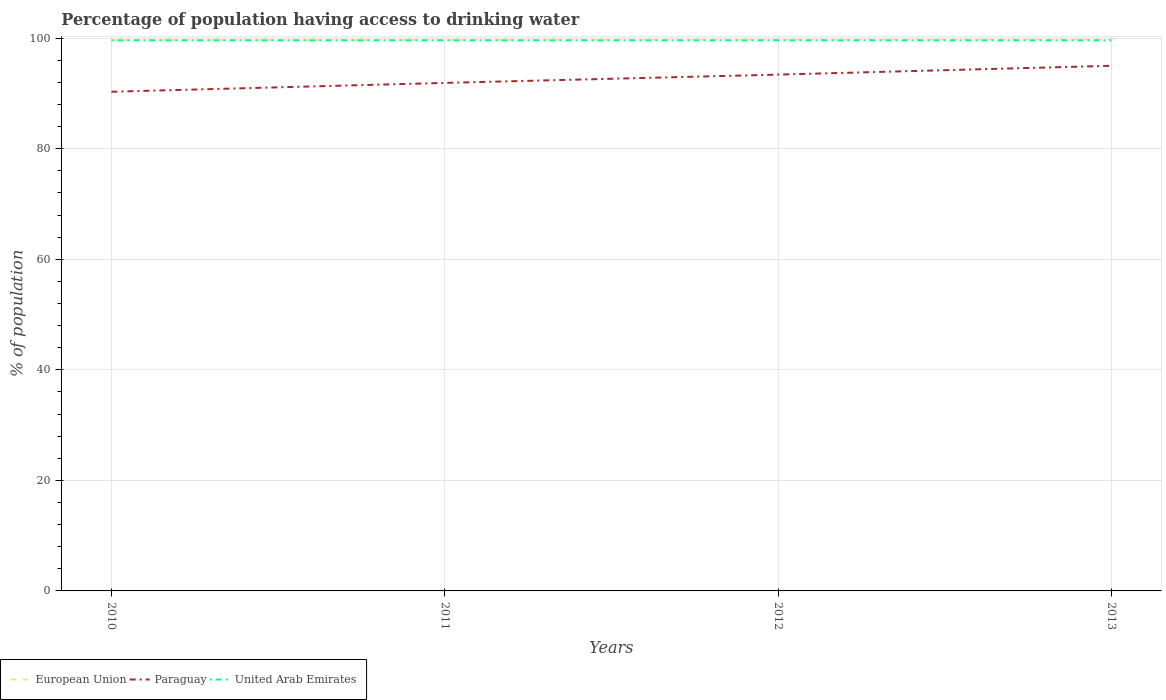Across all years, what is the maximum percentage of population having access to drinking water in Paraguay?
Your response must be concise. 90.3. What is the total percentage of population having access to drinking water in United Arab Emirates in the graph?
Your answer should be very brief. 0. What is the difference between the highest and the second highest percentage of population having access to drinking water in Paraguay?
Keep it short and to the point. 4.7. How many lines are there?
Your answer should be compact. 3. How many years are there in the graph?
Offer a very short reply. 4. What is the difference between two consecutive major ticks on the Y-axis?
Your response must be concise. 20. Does the graph contain any zero values?
Your answer should be very brief. No. How many legend labels are there?
Provide a short and direct response. 3. How are the legend labels stacked?
Provide a short and direct response. Horizontal. What is the title of the graph?
Make the answer very short. Percentage of population having access to drinking water. Does "Sri Lanka" appear as one of the legend labels in the graph?
Keep it short and to the point. No. What is the label or title of the X-axis?
Your answer should be very brief. Years. What is the label or title of the Y-axis?
Provide a succinct answer. % of population. What is the % of population in European Union in 2010?
Your answer should be very brief. 99.61. What is the % of population in Paraguay in 2010?
Give a very brief answer. 90.3. What is the % of population of United Arab Emirates in 2010?
Give a very brief answer. 99.6. What is the % of population of European Union in 2011?
Make the answer very short. 99.68. What is the % of population in Paraguay in 2011?
Provide a short and direct response. 91.9. What is the % of population in United Arab Emirates in 2011?
Give a very brief answer. 99.6. What is the % of population of European Union in 2012?
Your answer should be compact. 99.74. What is the % of population of Paraguay in 2012?
Make the answer very short. 93.4. What is the % of population of United Arab Emirates in 2012?
Ensure brevity in your answer.  99.6. What is the % of population of European Union in 2013?
Provide a short and direct response. 99.81. What is the % of population of United Arab Emirates in 2013?
Offer a terse response. 99.6. Across all years, what is the maximum % of population of European Union?
Your answer should be very brief. 99.81. Across all years, what is the maximum % of population in United Arab Emirates?
Your answer should be very brief. 99.6. Across all years, what is the minimum % of population of European Union?
Make the answer very short. 99.61. Across all years, what is the minimum % of population in Paraguay?
Make the answer very short. 90.3. Across all years, what is the minimum % of population of United Arab Emirates?
Provide a succinct answer. 99.6. What is the total % of population of European Union in the graph?
Offer a terse response. 398.84. What is the total % of population of Paraguay in the graph?
Offer a terse response. 370.6. What is the total % of population in United Arab Emirates in the graph?
Keep it short and to the point. 398.4. What is the difference between the % of population in European Union in 2010 and that in 2011?
Keep it short and to the point. -0.07. What is the difference between the % of population of Paraguay in 2010 and that in 2011?
Your response must be concise. -1.6. What is the difference between the % of population of European Union in 2010 and that in 2012?
Provide a succinct answer. -0.13. What is the difference between the % of population of United Arab Emirates in 2010 and that in 2012?
Your response must be concise. 0. What is the difference between the % of population of European Union in 2010 and that in 2013?
Give a very brief answer. -0.2. What is the difference between the % of population in Paraguay in 2010 and that in 2013?
Ensure brevity in your answer.  -4.7. What is the difference between the % of population of United Arab Emirates in 2010 and that in 2013?
Your answer should be very brief. 0. What is the difference between the % of population of European Union in 2011 and that in 2012?
Provide a short and direct response. -0.06. What is the difference between the % of population in United Arab Emirates in 2011 and that in 2012?
Give a very brief answer. 0. What is the difference between the % of population of European Union in 2011 and that in 2013?
Keep it short and to the point. -0.13. What is the difference between the % of population of European Union in 2012 and that in 2013?
Offer a terse response. -0.06. What is the difference between the % of population of United Arab Emirates in 2012 and that in 2013?
Make the answer very short. 0. What is the difference between the % of population in European Union in 2010 and the % of population in Paraguay in 2011?
Your response must be concise. 7.71. What is the difference between the % of population in European Union in 2010 and the % of population in United Arab Emirates in 2011?
Offer a very short reply. 0.01. What is the difference between the % of population of Paraguay in 2010 and the % of population of United Arab Emirates in 2011?
Ensure brevity in your answer.  -9.3. What is the difference between the % of population of European Union in 2010 and the % of population of Paraguay in 2012?
Provide a short and direct response. 6.21. What is the difference between the % of population of European Union in 2010 and the % of population of United Arab Emirates in 2012?
Your response must be concise. 0.01. What is the difference between the % of population of European Union in 2010 and the % of population of Paraguay in 2013?
Your answer should be very brief. 4.61. What is the difference between the % of population in European Union in 2010 and the % of population in United Arab Emirates in 2013?
Provide a succinct answer. 0.01. What is the difference between the % of population of Paraguay in 2010 and the % of population of United Arab Emirates in 2013?
Give a very brief answer. -9.3. What is the difference between the % of population of European Union in 2011 and the % of population of Paraguay in 2012?
Give a very brief answer. 6.28. What is the difference between the % of population of European Union in 2011 and the % of population of United Arab Emirates in 2012?
Your answer should be very brief. 0.08. What is the difference between the % of population in Paraguay in 2011 and the % of population in United Arab Emirates in 2012?
Ensure brevity in your answer.  -7.7. What is the difference between the % of population in European Union in 2011 and the % of population in Paraguay in 2013?
Offer a terse response. 4.68. What is the difference between the % of population of European Union in 2011 and the % of population of United Arab Emirates in 2013?
Make the answer very short. 0.08. What is the difference between the % of population in European Union in 2012 and the % of population in Paraguay in 2013?
Offer a very short reply. 4.74. What is the difference between the % of population in European Union in 2012 and the % of population in United Arab Emirates in 2013?
Your answer should be very brief. 0.14. What is the difference between the % of population in Paraguay in 2012 and the % of population in United Arab Emirates in 2013?
Keep it short and to the point. -6.2. What is the average % of population of European Union per year?
Provide a short and direct response. 99.71. What is the average % of population in Paraguay per year?
Keep it short and to the point. 92.65. What is the average % of population in United Arab Emirates per year?
Provide a short and direct response. 99.6. In the year 2010, what is the difference between the % of population of European Union and % of population of Paraguay?
Offer a terse response. 9.31. In the year 2010, what is the difference between the % of population of European Union and % of population of United Arab Emirates?
Offer a terse response. 0.01. In the year 2011, what is the difference between the % of population in European Union and % of population in Paraguay?
Make the answer very short. 7.78. In the year 2011, what is the difference between the % of population of European Union and % of population of United Arab Emirates?
Your response must be concise. 0.08. In the year 2011, what is the difference between the % of population of Paraguay and % of population of United Arab Emirates?
Give a very brief answer. -7.7. In the year 2012, what is the difference between the % of population of European Union and % of population of Paraguay?
Offer a terse response. 6.34. In the year 2012, what is the difference between the % of population in European Union and % of population in United Arab Emirates?
Offer a terse response. 0.14. In the year 2013, what is the difference between the % of population in European Union and % of population in Paraguay?
Offer a very short reply. 4.8. In the year 2013, what is the difference between the % of population in European Union and % of population in United Arab Emirates?
Offer a very short reply. 0.2. In the year 2013, what is the difference between the % of population of Paraguay and % of population of United Arab Emirates?
Your answer should be very brief. -4.6. What is the ratio of the % of population of European Union in 2010 to that in 2011?
Your response must be concise. 1. What is the ratio of the % of population in Paraguay in 2010 to that in 2011?
Keep it short and to the point. 0.98. What is the ratio of the % of population of United Arab Emirates in 2010 to that in 2011?
Your answer should be compact. 1. What is the ratio of the % of population of European Union in 2010 to that in 2012?
Offer a terse response. 1. What is the ratio of the % of population in Paraguay in 2010 to that in 2012?
Offer a very short reply. 0.97. What is the ratio of the % of population of European Union in 2010 to that in 2013?
Provide a succinct answer. 1. What is the ratio of the % of population of Paraguay in 2010 to that in 2013?
Provide a short and direct response. 0.95. What is the ratio of the % of population of United Arab Emirates in 2010 to that in 2013?
Offer a terse response. 1. What is the ratio of the % of population of European Union in 2011 to that in 2012?
Your answer should be compact. 1. What is the ratio of the % of population in Paraguay in 2011 to that in 2012?
Offer a terse response. 0.98. What is the ratio of the % of population of United Arab Emirates in 2011 to that in 2012?
Make the answer very short. 1. What is the ratio of the % of population of European Union in 2011 to that in 2013?
Your response must be concise. 1. What is the ratio of the % of population of Paraguay in 2011 to that in 2013?
Your response must be concise. 0.97. What is the ratio of the % of population in United Arab Emirates in 2011 to that in 2013?
Make the answer very short. 1. What is the ratio of the % of population in Paraguay in 2012 to that in 2013?
Offer a very short reply. 0.98. What is the ratio of the % of population in United Arab Emirates in 2012 to that in 2013?
Make the answer very short. 1. What is the difference between the highest and the second highest % of population of European Union?
Keep it short and to the point. 0.06. What is the difference between the highest and the lowest % of population of European Union?
Provide a succinct answer. 0.2. 